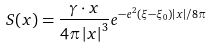Convert formula to latex. <formula><loc_0><loc_0><loc_500><loc_500>S ( x ) = \frac { \gamma \cdot x } { 4 \pi \left | x \right | ^ { 3 } } e ^ { - e ^ { 2 } ( \xi - \xi _ { 0 } ) \left | x \right | / 8 \pi }</formula> 